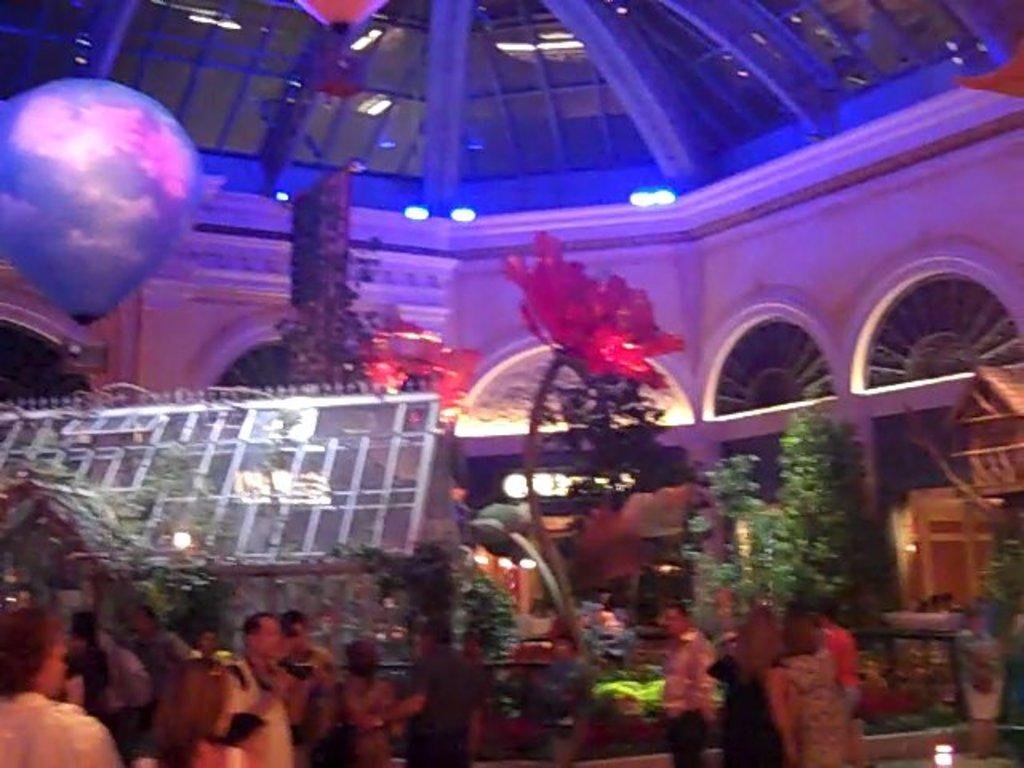What is happening in the image? There are people standing in the image. Where are the people standing? The people are standing on the floor. What else can be seen in the image besides the people? There are plants visible in the image. Are there any objects or items in the image that are not related to the people or plants? Yes, there is a decoration item present in the image. Can you hear a girl whistling in the image? There is no girl whistling in the image, as there is no mention of a girl or whistling in the provided facts. 